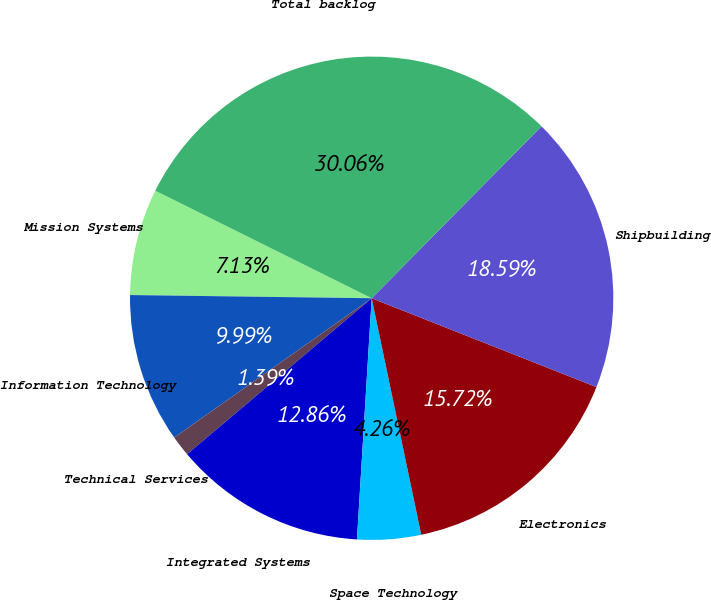<chart> <loc_0><loc_0><loc_500><loc_500><pie_chart><fcel>Mission Systems<fcel>Information Technology<fcel>Technical Services<fcel>Integrated Systems<fcel>Space Technology<fcel>Electronics<fcel>Shipbuilding<fcel>Total backlog<nl><fcel>7.13%<fcel>9.99%<fcel>1.39%<fcel>12.86%<fcel>4.26%<fcel>15.72%<fcel>18.59%<fcel>30.06%<nl></chart> 